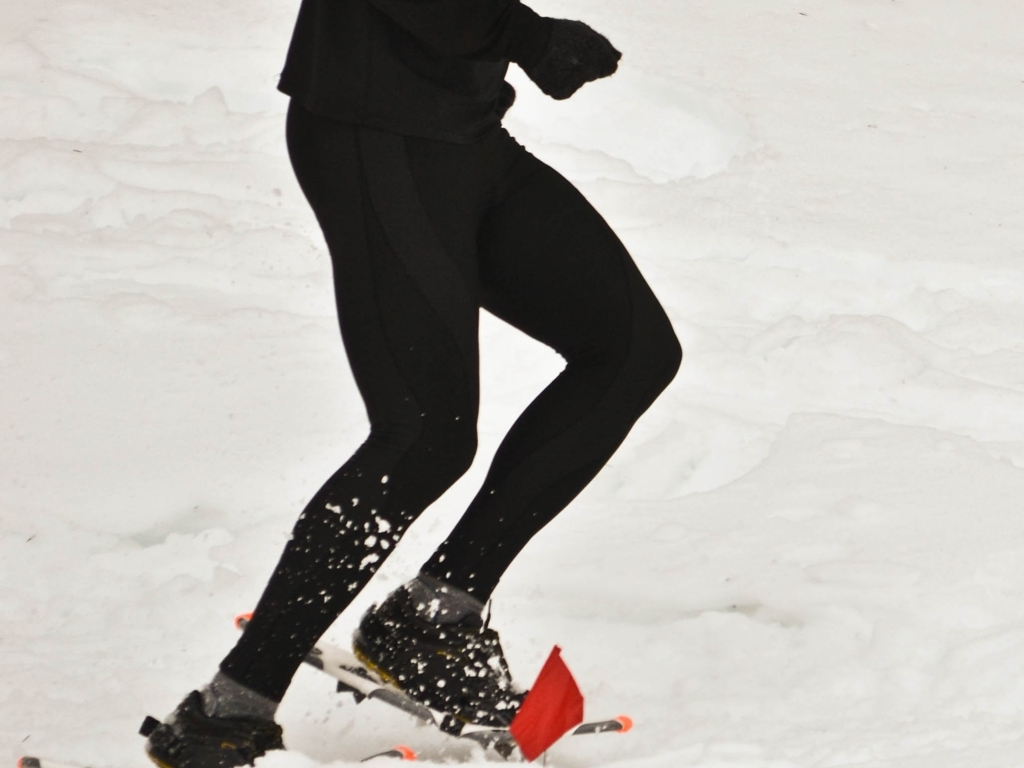What attire is the runner wearing and is it suitable for the activity depicted? The runner is dressed in cold-weather athletic gear, which includes a long-sleeve top, leggings, gloves, and appropriate running shoes likely equipped with traction enhancements for snowy conditions. This attire is suitable for maintaining body warmth and flexibility during outdoor exercise in a cold environment. 